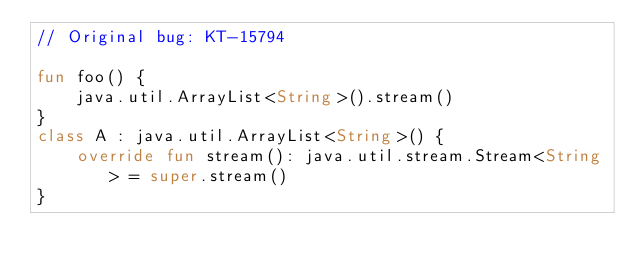<code> <loc_0><loc_0><loc_500><loc_500><_Kotlin_>// Original bug: KT-15794

fun foo() {
    java.util.ArrayList<String>().stream()
}
class A : java.util.ArrayList<String>() {
    override fun stream(): java.util.stream.Stream<String> = super.stream()
}
</code> 